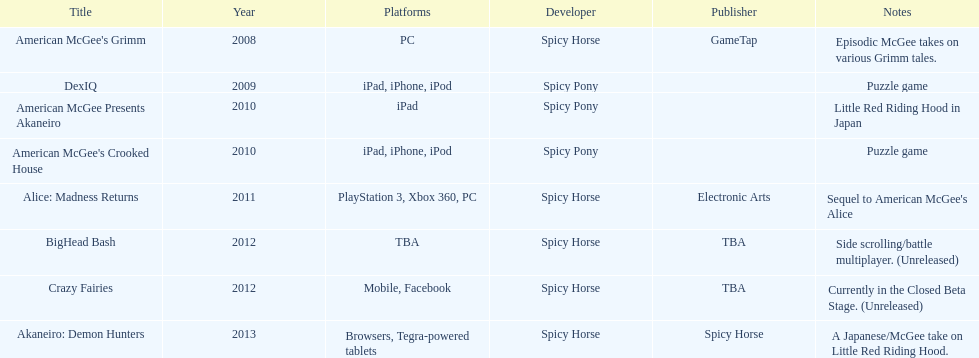Spicy pony released a total of three games; their game, "american mcgee's crooked house" was released on which platforms? Ipad, iphone, ipod. I'm looking to parse the entire table for insights. Could you assist me with that? {'header': ['Title', 'Year', 'Platforms', 'Developer', 'Publisher', 'Notes'], 'rows': [["American McGee's Grimm", '2008', 'PC', 'Spicy Horse', 'GameTap', 'Episodic McGee takes on various Grimm tales.'], ['DexIQ', '2009', 'iPad, iPhone, iPod', 'Spicy Pony', '', 'Puzzle game'], ['American McGee Presents Akaneiro', '2010', 'iPad', 'Spicy Pony', '', 'Little Red Riding Hood in Japan'], ["American McGee's Crooked House", '2010', 'iPad, iPhone, iPod', 'Spicy Pony', '', 'Puzzle game'], ['Alice: Madness Returns', '2011', 'PlayStation 3, Xbox 360, PC', 'Spicy Horse', 'Electronic Arts', "Sequel to American McGee's Alice"], ['BigHead Bash', '2012', 'TBA', 'Spicy Horse', 'TBA', 'Side scrolling/battle multiplayer. (Unreleased)'], ['Crazy Fairies', '2012', 'Mobile, Facebook', 'Spicy Horse', 'TBA', 'Currently in the Closed Beta Stage. (Unreleased)'], ['Akaneiro: Demon Hunters', '2013', 'Browsers, Tegra-powered tablets', 'Spicy Horse', 'Spicy Horse', 'A Japanese/McGee take on Little Red Riding Hood.']]} 